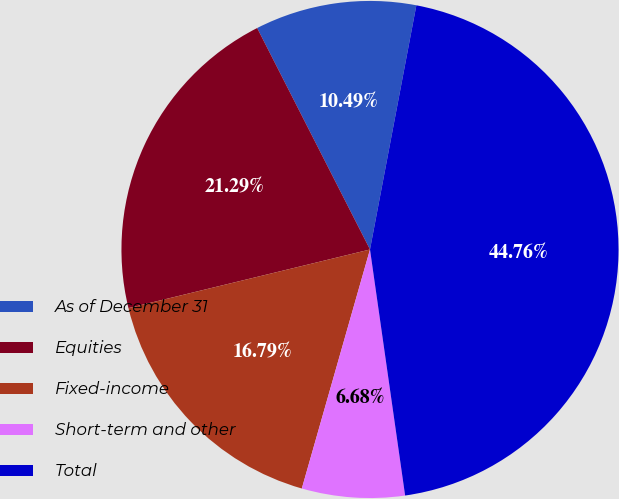<chart> <loc_0><loc_0><loc_500><loc_500><pie_chart><fcel>As of December 31<fcel>Equities<fcel>Fixed-income<fcel>Short-term and other<fcel>Total<nl><fcel>10.49%<fcel>21.29%<fcel>16.79%<fcel>6.68%<fcel>44.76%<nl></chart> 